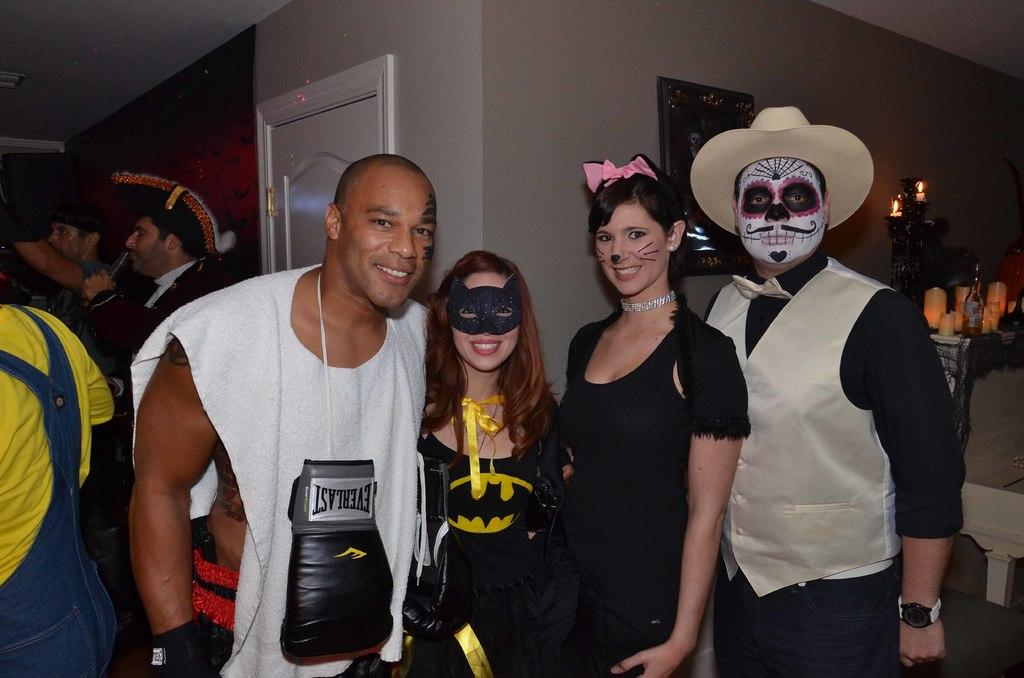<image>
Present a compact description of the photo's key features. a group of people in halloween costumes including a boxer with everlast gloves 